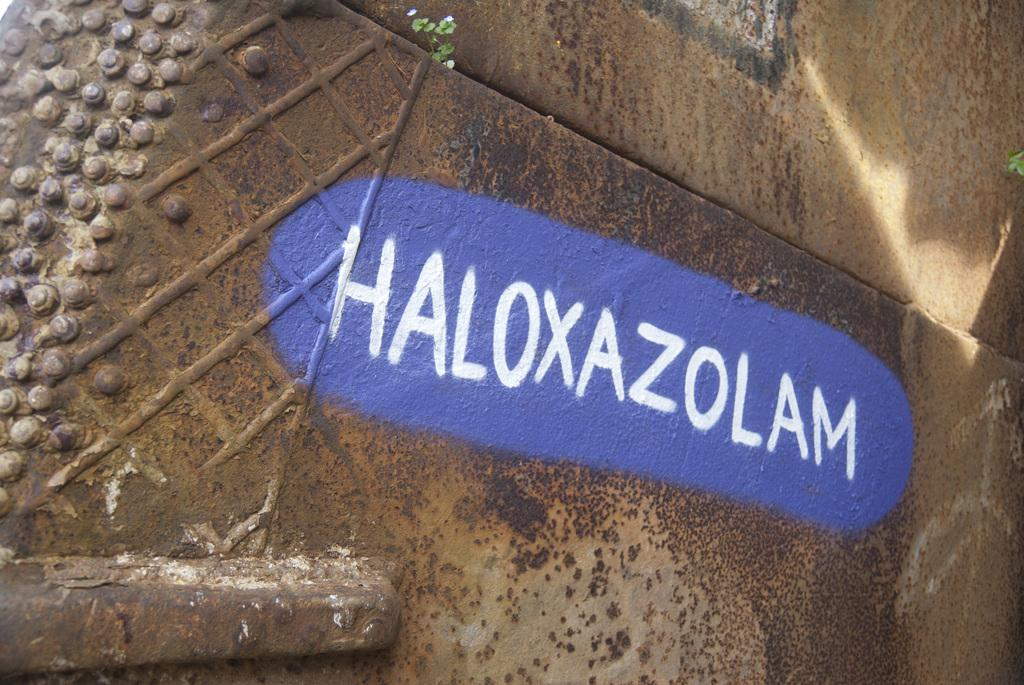What can be seen written in the image? There is a name written in the image. How is the name written? The name is written with white paint. What is the background color of the name? The background color of the name is purple. On what surface is the name written? The name is written on a surface. What type of haircut does the name have in the image? The name does not have a haircut, as it is a written name and not a person. 